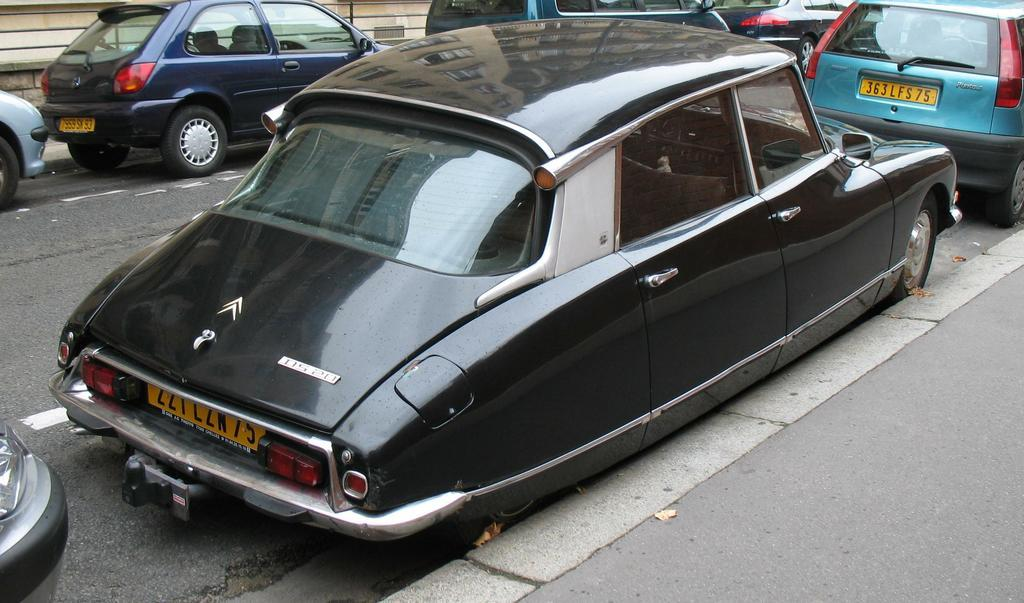What can be seen on the road in the image? There are vehicles on the road in the image. What can be said about the appearance of the vehicles? The vehicles are colorful. What specific detail about the vehicles can be observed? The number plates of the vehicles are visible. What is visible in the background of the image? There is a wall visible in the background of the image. What type of wilderness can be seen in the image? There is no wilderness present in the image; it features vehicles on a road with a wall in the background. What muscle is being exercised by the vehicles in the image? Vehicles do not have muscles, so this question is not applicable to the image. 